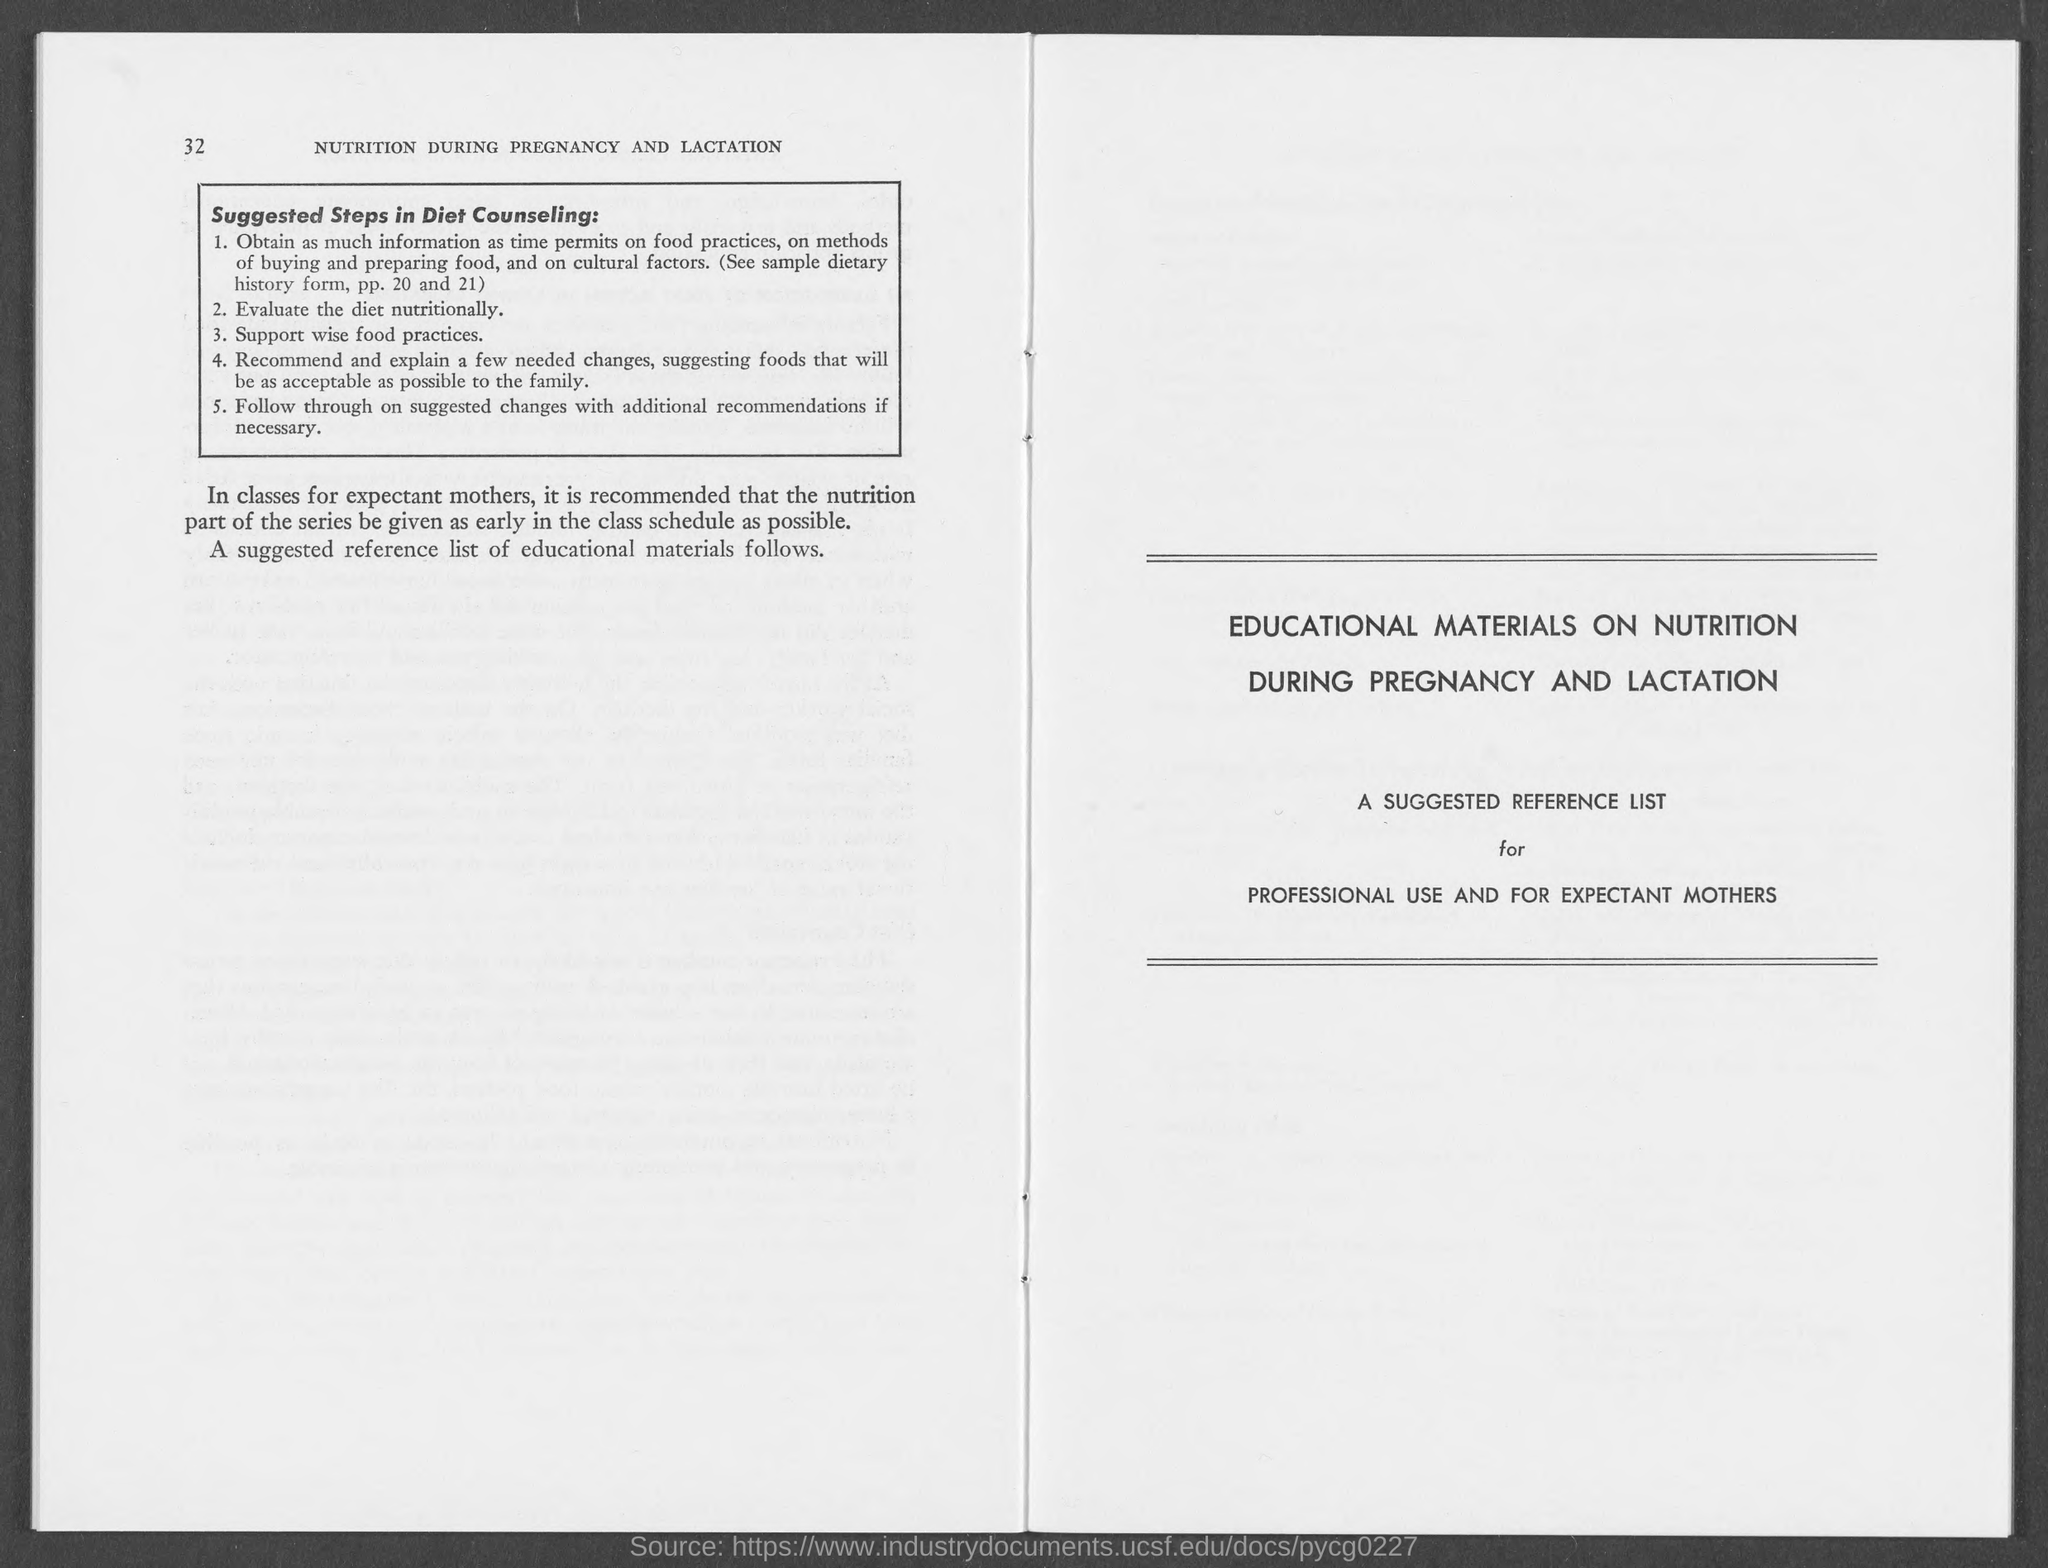Identify some key points in this picture. The number at the top-left corner of the page is 32. 